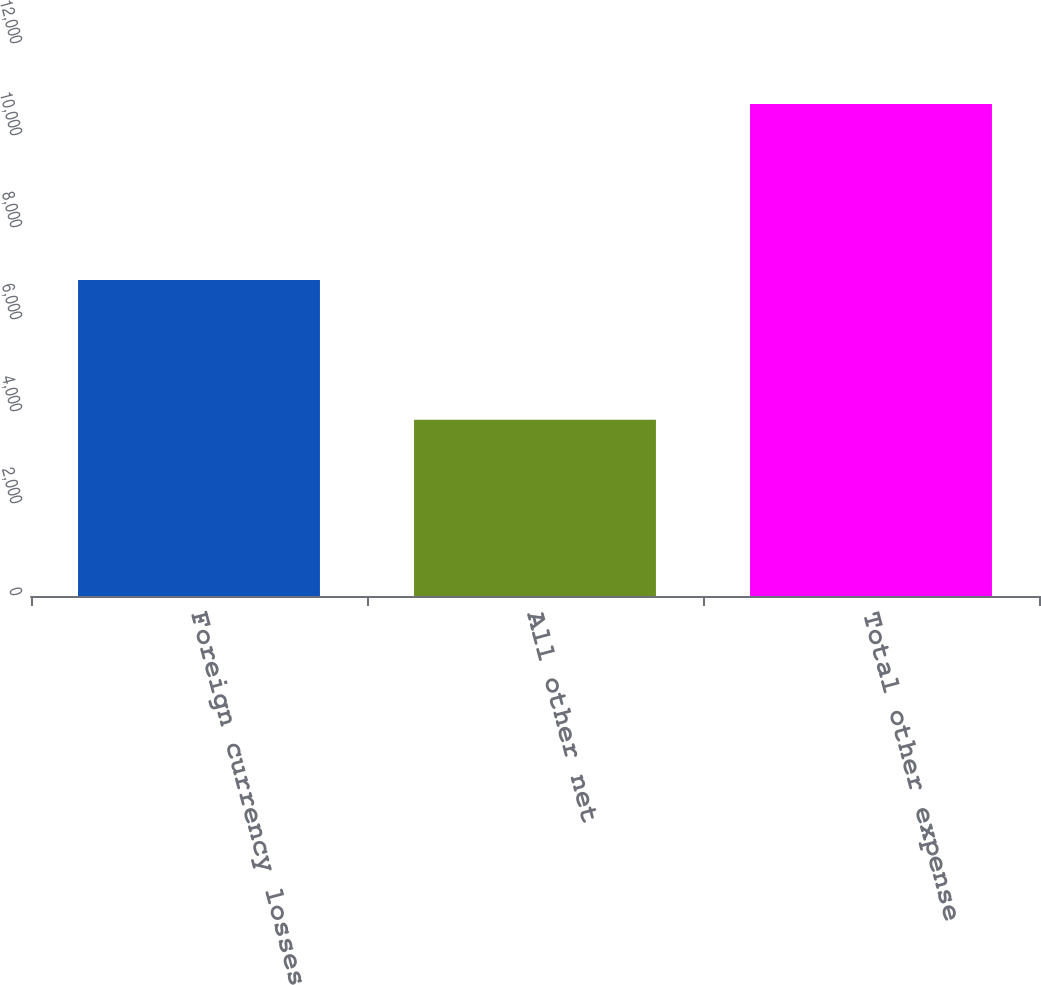Convert chart. <chart><loc_0><loc_0><loc_500><loc_500><bar_chart><fcel>Foreign currency losses<fcel>All other net<fcel>Total other expense<nl><fcel>6869<fcel>3829<fcel>10698<nl></chart> 